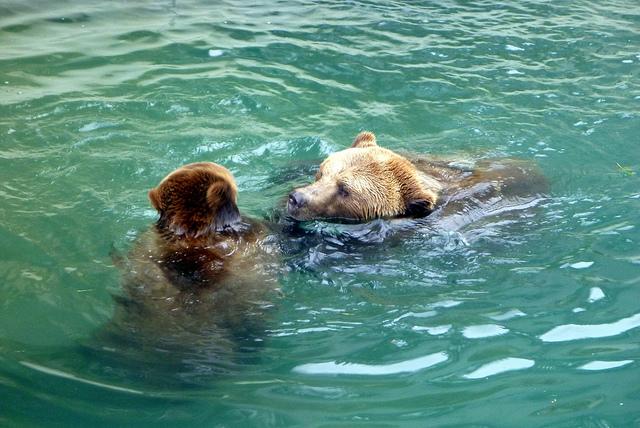How many bears are there?
Quick response, please. 2. What color is the water?
Concise answer only. Green. Does this look like a natural setting?
Concise answer only. No. 